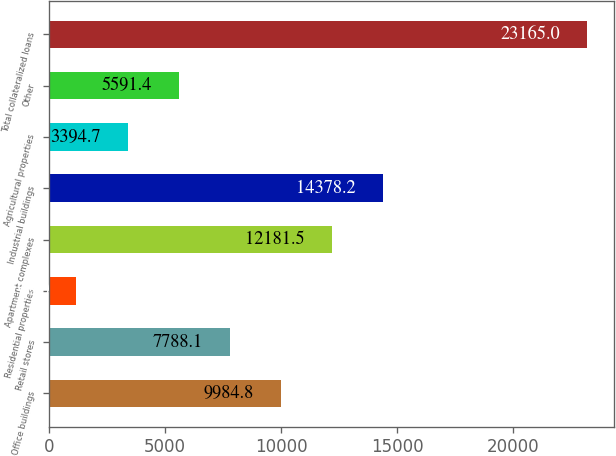Convert chart. <chart><loc_0><loc_0><loc_500><loc_500><bar_chart><fcel>Office buildings<fcel>Retail stores<fcel>Residential properties<fcel>Apartment complexes<fcel>Industrial buildings<fcel>Agricultural properties<fcel>Other<fcel>Total collateralized loans<nl><fcel>9984.8<fcel>7788.1<fcel>1198<fcel>12181.5<fcel>14378.2<fcel>3394.7<fcel>5591.4<fcel>23165<nl></chart> 